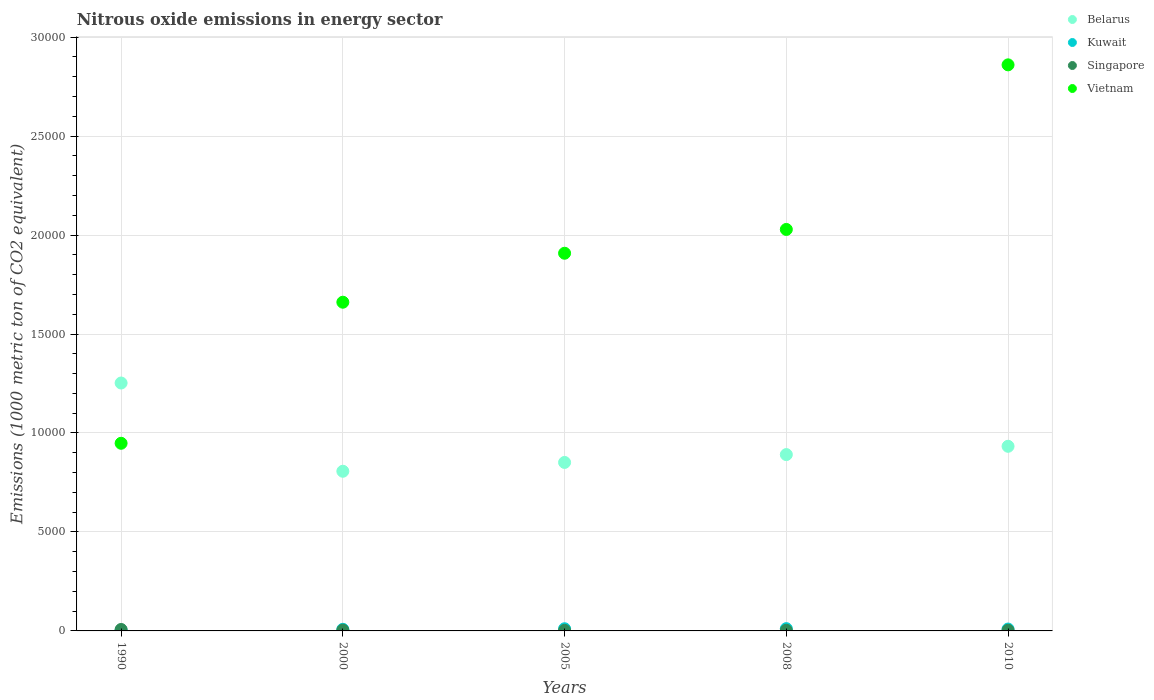How many different coloured dotlines are there?
Your answer should be very brief. 4. What is the amount of nitrous oxide emitted in Vietnam in 1990?
Offer a terse response. 9479.8. Across all years, what is the maximum amount of nitrous oxide emitted in Belarus?
Offer a very short reply. 1.25e+04. Across all years, what is the minimum amount of nitrous oxide emitted in Kuwait?
Your response must be concise. 36.7. What is the total amount of nitrous oxide emitted in Singapore in the graph?
Your answer should be compact. 210.2. What is the difference between the amount of nitrous oxide emitted in Singapore in 2000 and that in 2008?
Provide a short and direct response. 7.9. What is the difference between the amount of nitrous oxide emitted in Belarus in 2000 and the amount of nitrous oxide emitted in Vietnam in 2008?
Give a very brief answer. -1.22e+04. What is the average amount of nitrous oxide emitted in Kuwait per year?
Provide a succinct answer. 87.64. In the year 1990, what is the difference between the amount of nitrous oxide emitted in Kuwait and amount of nitrous oxide emitted in Singapore?
Your answer should be compact. -36.8. What is the ratio of the amount of nitrous oxide emitted in Singapore in 2000 to that in 2008?
Your answer should be compact. 1.24. Is the amount of nitrous oxide emitted in Kuwait in 2000 less than that in 2010?
Your answer should be very brief. Yes. Is the difference between the amount of nitrous oxide emitted in Kuwait in 2008 and 2010 greater than the difference between the amount of nitrous oxide emitted in Singapore in 2008 and 2010?
Give a very brief answer. Yes. What is the difference between the highest and the second highest amount of nitrous oxide emitted in Kuwait?
Offer a very short reply. 5.1. What is the difference between the highest and the lowest amount of nitrous oxide emitted in Kuwait?
Offer a terse response. 78.2. In how many years, is the amount of nitrous oxide emitted in Belarus greater than the average amount of nitrous oxide emitted in Belarus taken over all years?
Your answer should be very brief. 1. Is the sum of the amount of nitrous oxide emitted in Belarus in 1990 and 2005 greater than the maximum amount of nitrous oxide emitted in Vietnam across all years?
Your response must be concise. No. Is the amount of nitrous oxide emitted in Singapore strictly greater than the amount of nitrous oxide emitted in Belarus over the years?
Your answer should be very brief. No. How many dotlines are there?
Offer a terse response. 4. Are the values on the major ticks of Y-axis written in scientific E-notation?
Give a very brief answer. No. What is the title of the graph?
Offer a terse response. Nitrous oxide emissions in energy sector. What is the label or title of the X-axis?
Ensure brevity in your answer.  Years. What is the label or title of the Y-axis?
Your response must be concise. Emissions (1000 metric ton of CO2 equivalent). What is the Emissions (1000 metric ton of CO2 equivalent) of Belarus in 1990?
Offer a very short reply. 1.25e+04. What is the Emissions (1000 metric ton of CO2 equivalent) of Kuwait in 1990?
Offer a very short reply. 36.7. What is the Emissions (1000 metric ton of CO2 equivalent) in Singapore in 1990?
Your answer should be compact. 73.5. What is the Emissions (1000 metric ton of CO2 equivalent) of Vietnam in 1990?
Your answer should be very brief. 9479.8. What is the Emissions (1000 metric ton of CO2 equivalent) in Belarus in 2000?
Provide a succinct answer. 8066.2. What is the Emissions (1000 metric ton of CO2 equivalent) of Kuwait in 2000?
Provide a succinct answer. 81.9. What is the Emissions (1000 metric ton of CO2 equivalent) in Singapore in 2000?
Ensure brevity in your answer.  40.5. What is the Emissions (1000 metric ton of CO2 equivalent) in Vietnam in 2000?
Your answer should be compact. 1.66e+04. What is the Emissions (1000 metric ton of CO2 equivalent) of Belarus in 2005?
Provide a succinct answer. 8511.9. What is the Emissions (1000 metric ton of CO2 equivalent) in Kuwait in 2005?
Provide a short and direct response. 109.8. What is the Emissions (1000 metric ton of CO2 equivalent) in Singapore in 2005?
Provide a succinct answer. 29.5. What is the Emissions (1000 metric ton of CO2 equivalent) of Vietnam in 2005?
Offer a terse response. 1.91e+04. What is the Emissions (1000 metric ton of CO2 equivalent) of Belarus in 2008?
Offer a terse response. 8908.4. What is the Emissions (1000 metric ton of CO2 equivalent) of Kuwait in 2008?
Give a very brief answer. 114.9. What is the Emissions (1000 metric ton of CO2 equivalent) in Singapore in 2008?
Ensure brevity in your answer.  32.6. What is the Emissions (1000 metric ton of CO2 equivalent) in Vietnam in 2008?
Your answer should be very brief. 2.03e+04. What is the Emissions (1000 metric ton of CO2 equivalent) in Belarus in 2010?
Your answer should be very brief. 9327.9. What is the Emissions (1000 metric ton of CO2 equivalent) in Kuwait in 2010?
Your answer should be very brief. 94.9. What is the Emissions (1000 metric ton of CO2 equivalent) of Singapore in 2010?
Make the answer very short. 34.1. What is the Emissions (1000 metric ton of CO2 equivalent) of Vietnam in 2010?
Provide a succinct answer. 2.86e+04. Across all years, what is the maximum Emissions (1000 metric ton of CO2 equivalent) in Belarus?
Make the answer very short. 1.25e+04. Across all years, what is the maximum Emissions (1000 metric ton of CO2 equivalent) of Kuwait?
Your response must be concise. 114.9. Across all years, what is the maximum Emissions (1000 metric ton of CO2 equivalent) of Singapore?
Your answer should be very brief. 73.5. Across all years, what is the maximum Emissions (1000 metric ton of CO2 equivalent) in Vietnam?
Provide a succinct answer. 2.86e+04. Across all years, what is the minimum Emissions (1000 metric ton of CO2 equivalent) of Belarus?
Give a very brief answer. 8066.2. Across all years, what is the minimum Emissions (1000 metric ton of CO2 equivalent) in Kuwait?
Ensure brevity in your answer.  36.7. Across all years, what is the minimum Emissions (1000 metric ton of CO2 equivalent) of Singapore?
Your response must be concise. 29.5. Across all years, what is the minimum Emissions (1000 metric ton of CO2 equivalent) of Vietnam?
Make the answer very short. 9479.8. What is the total Emissions (1000 metric ton of CO2 equivalent) of Belarus in the graph?
Keep it short and to the point. 4.73e+04. What is the total Emissions (1000 metric ton of CO2 equivalent) of Kuwait in the graph?
Give a very brief answer. 438.2. What is the total Emissions (1000 metric ton of CO2 equivalent) in Singapore in the graph?
Give a very brief answer. 210.2. What is the total Emissions (1000 metric ton of CO2 equivalent) of Vietnam in the graph?
Your answer should be compact. 9.40e+04. What is the difference between the Emissions (1000 metric ton of CO2 equivalent) of Belarus in 1990 and that in 2000?
Make the answer very short. 4458.4. What is the difference between the Emissions (1000 metric ton of CO2 equivalent) of Kuwait in 1990 and that in 2000?
Your answer should be very brief. -45.2. What is the difference between the Emissions (1000 metric ton of CO2 equivalent) in Vietnam in 1990 and that in 2000?
Offer a terse response. -7126.8. What is the difference between the Emissions (1000 metric ton of CO2 equivalent) of Belarus in 1990 and that in 2005?
Make the answer very short. 4012.7. What is the difference between the Emissions (1000 metric ton of CO2 equivalent) of Kuwait in 1990 and that in 2005?
Keep it short and to the point. -73.1. What is the difference between the Emissions (1000 metric ton of CO2 equivalent) of Singapore in 1990 and that in 2005?
Offer a very short reply. 44. What is the difference between the Emissions (1000 metric ton of CO2 equivalent) of Vietnam in 1990 and that in 2005?
Ensure brevity in your answer.  -9601.2. What is the difference between the Emissions (1000 metric ton of CO2 equivalent) in Belarus in 1990 and that in 2008?
Your answer should be compact. 3616.2. What is the difference between the Emissions (1000 metric ton of CO2 equivalent) in Kuwait in 1990 and that in 2008?
Offer a terse response. -78.2. What is the difference between the Emissions (1000 metric ton of CO2 equivalent) of Singapore in 1990 and that in 2008?
Your response must be concise. 40.9. What is the difference between the Emissions (1000 metric ton of CO2 equivalent) of Vietnam in 1990 and that in 2008?
Give a very brief answer. -1.08e+04. What is the difference between the Emissions (1000 metric ton of CO2 equivalent) in Belarus in 1990 and that in 2010?
Your answer should be compact. 3196.7. What is the difference between the Emissions (1000 metric ton of CO2 equivalent) in Kuwait in 1990 and that in 2010?
Offer a terse response. -58.2. What is the difference between the Emissions (1000 metric ton of CO2 equivalent) of Singapore in 1990 and that in 2010?
Offer a very short reply. 39.4. What is the difference between the Emissions (1000 metric ton of CO2 equivalent) in Vietnam in 1990 and that in 2010?
Offer a very short reply. -1.91e+04. What is the difference between the Emissions (1000 metric ton of CO2 equivalent) of Belarus in 2000 and that in 2005?
Your answer should be very brief. -445.7. What is the difference between the Emissions (1000 metric ton of CO2 equivalent) in Kuwait in 2000 and that in 2005?
Your answer should be very brief. -27.9. What is the difference between the Emissions (1000 metric ton of CO2 equivalent) of Vietnam in 2000 and that in 2005?
Provide a succinct answer. -2474.4. What is the difference between the Emissions (1000 metric ton of CO2 equivalent) of Belarus in 2000 and that in 2008?
Make the answer very short. -842.2. What is the difference between the Emissions (1000 metric ton of CO2 equivalent) in Kuwait in 2000 and that in 2008?
Ensure brevity in your answer.  -33. What is the difference between the Emissions (1000 metric ton of CO2 equivalent) in Singapore in 2000 and that in 2008?
Provide a short and direct response. 7.9. What is the difference between the Emissions (1000 metric ton of CO2 equivalent) in Vietnam in 2000 and that in 2008?
Make the answer very short. -3676.6. What is the difference between the Emissions (1000 metric ton of CO2 equivalent) of Belarus in 2000 and that in 2010?
Make the answer very short. -1261.7. What is the difference between the Emissions (1000 metric ton of CO2 equivalent) in Singapore in 2000 and that in 2010?
Offer a very short reply. 6.4. What is the difference between the Emissions (1000 metric ton of CO2 equivalent) in Vietnam in 2000 and that in 2010?
Make the answer very short. -1.20e+04. What is the difference between the Emissions (1000 metric ton of CO2 equivalent) of Belarus in 2005 and that in 2008?
Offer a very short reply. -396.5. What is the difference between the Emissions (1000 metric ton of CO2 equivalent) of Singapore in 2005 and that in 2008?
Offer a very short reply. -3.1. What is the difference between the Emissions (1000 metric ton of CO2 equivalent) in Vietnam in 2005 and that in 2008?
Offer a very short reply. -1202.2. What is the difference between the Emissions (1000 metric ton of CO2 equivalent) in Belarus in 2005 and that in 2010?
Keep it short and to the point. -816. What is the difference between the Emissions (1000 metric ton of CO2 equivalent) of Vietnam in 2005 and that in 2010?
Your answer should be very brief. -9517.8. What is the difference between the Emissions (1000 metric ton of CO2 equivalent) of Belarus in 2008 and that in 2010?
Make the answer very short. -419.5. What is the difference between the Emissions (1000 metric ton of CO2 equivalent) of Singapore in 2008 and that in 2010?
Your answer should be compact. -1.5. What is the difference between the Emissions (1000 metric ton of CO2 equivalent) in Vietnam in 2008 and that in 2010?
Your answer should be compact. -8315.6. What is the difference between the Emissions (1000 metric ton of CO2 equivalent) of Belarus in 1990 and the Emissions (1000 metric ton of CO2 equivalent) of Kuwait in 2000?
Offer a terse response. 1.24e+04. What is the difference between the Emissions (1000 metric ton of CO2 equivalent) in Belarus in 1990 and the Emissions (1000 metric ton of CO2 equivalent) in Singapore in 2000?
Keep it short and to the point. 1.25e+04. What is the difference between the Emissions (1000 metric ton of CO2 equivalent) of Belarus in 1990 and the Emissions (1000 metric ton of CO2 equivalent) of Vietnam in 2000?
Provide a succinct answer. -4082. What is the difference between the Emissions (1000 metric ton of CO2 equivalent) in Kuwait in 1990 and the Emissions (1000 metric ton of CO2 equivalent) in Singapore in 2000?
Provide a succinct answer. -3.8. What is the difference between the Emissions (1000 metric ton of CO2 equivalent) in Kuwait in 1990 and the Emissions (1000 metric ton of CO2 equivalent) in Vietnam in 2000?
Make the answer very short. -1.66e+04. What is the difference between the Emissions (1000 metric ton of CO2 equivalent) in Singapore in 1990 and the Emissions (1000 metric ton of CO2 equivalent) in Vietnam in 2000?
Provide a succinct answer. -1.65e+04. What is the difference between the Emissions (1000 metric ton of CO2 equivalent) of Belarus in 1990 and the Emissions (1000 metric ton of CO2 equivalent) of Kuwait in 2005?
Offer a terse response. 1.24e+04. What is the difference between the Emissions (1000 metric ton of CO2 equivalent) in Belarus in 1990 and the Emissions (1000 metric ton of CO2 equivalent) in Singapore in 2005?
Your response must be concise. 1.25e+04. What is the difference between the Emissions (1000 metric ton of CO2 equivalent) in Belarus in 1990 and the Emissions (1000 metric ton of CO2 equivalent) in Vietnam in 2005?
Give a very brief answer. -6556.4. What is the difference between the Emissions (1000 metric ton of CO2 equivalent) in Kuwait in 1990 and the Emissions (1000 metric ton of CO2 equivalent) in Vietnam in 2005?
Your answer should be compact. -1.90e+04. What is the difference between the Emissions (1000 metric ton of CO2 equivalent) in Singapore in 1990 and the Emissions (1000 metric ton of CO2 equivalent) in Vietnam in 2005?
Provide a short and direct response. -1.90e+04. What is the difference between the Emissions (1000 metric ton of CO2 equivalent) in Belarus in 1990 and the Emissions (1000 metric ton of CO2 equivalent) in Kuwait in 2008?
Provide a short and direct response. 1.24e+04. What is the difference between the Emissions (1000 metric ton of CO2 equivalent) in Belarus in 1990 and the Emissions (1000 metric ton of CO2 equivalent) in Singapore in 2008?
Offer a terse response. 1.25e+04. What is the difference between the Emissions (1000 metric ton of CO2 equivalent) in Belarus in 1990 and the Emissions (1000 metric ton of CO2 equivalent) in Vietnam in 2008?
Provide a short and direct response. -7758.6. What is the difference between the Emissions (1000 metric ton of CO2 equivalent) of Kuwait in 1990 and the Emissions (1000 metric ton of CO2 equivalent) of Singapore in 2008?
Provide a succinct answer. 4.1. What is the difference between the Emissions (1000 metric ton of CO2 equivalent) in Kuwait in 1990 and the Emissions (1000 metric ton of CO2 equivalent) in Vietnam in 2008?
Ensure brevity in your answer.  -2.02e+04. What is the difference between the Emissions (1000 metric ton of CO2 equivalent) in Singapore in 1990 and the Emissions (1000 metric ton of CO2 equivalent) in Vietnam in 2008?
Provide a short and direct response. -2.02e+04. What is the difference between the Emissions (1000 metric ton of CO2 equivalent) of Belarus in 1990 and the Emissions (1000 metric ton of CO2 equivalent) of Kuwait in 2010?
Provide a short and direct response. 1.24e+04. What is the difference between the Emissions (1000 metric ton of CO2 equivalent) of Belarus in 1990 and the Emissions (1000 metric ton of CO2 equivalent) of Singapore in 2010?
Your response must be concise. 1.25e+04. What is the difference between the Emissions (1000 metric ton of CO2 equivalent) of Belarus in 1990 and the Emissions (1000 metric ton of CO2 equivalent) of Vietnam in 2010?
Make the answer very short. -1.61e+04. What is the difference between the Emissions (1000 metric ton of CO2 equivalent) of Kuwait in 1990 and the Emissions (1000 metric ton of CO2 equivalent) of Vietnam in 2010?
Give a very brief answer. -2.86e+04. What is the difference between the Emissions (1000 metric ton of CO2 equivalent) of Singapore in 1990 and the Emissions (1000 metric ton of CO2 equivalent) of Vietnam in 2010?
Offer a terse response. -2.85e+04. What is the difference between the Emissions (1000 metric ton of CO2 equivalent) of Belarus in 2000 and the Emissions (1000 metric ton of CO2 equivalent) of Kuwait in 2005?
Your answer should be very brief. 7956.4. What is the difference between the Emissions (1000 metric ton of CO2 equivalent) of Belarus in 2000 and the Emissions (1000 metric ton of CO2 equivalent) of Singapore in 2005?
Keep it short and to the point. 8036.7. What is the difference between the Emissions (1000 metric ton of CO2 equivalent) of Belarus in 2000 and the Emissions (1000 metric ton of CO2 equivalent) of Vietnam in 2005?
Give a very brief answer. -1.10e+04. What is the difference between the Emissions (1000 metric ton of CO2 equivalent) in Kuwait in 2000 and the Emissions (1000 metric ton of CO2 equivalent) in Singapore in 2005?
Provide a short and direct response. 52.4. What is the difference between the Emissions (1000 metric ton of CO2 equivalent) in Kuwait in 2000 and the Emissions (1000 metric ton of CO2 equivalent) in Vietnam in 2005?
Keep it short and to the point. -1.90e+04. What is the difference between the Emissions (1000 metric ton of CO2 equivalent) of Singapore in 2000 and the Emissions (1000 metric ton of CO2 equivalent) of Vietnam in 2005?
Ensure brevity in your answer.  -1.90e+04. What is the difference between the Emissions (1000 metric ton of CO2 equivalent) of Belarus in 2000 and the Emissions (1000 metric ton of CO2 equivalent) of Kuwait in 2008?
Keep it short and to the point. 7951.3. What is the difference between the Emissions (1000 metric ton of CO2 equivalent) in Belarus in 2000 and the Emissions (1000 metric ton of CO2 equivalent) in Singapore in 2008?
Make the answer very short. 8033.6. What is the difference between the Emissions (1000 metric ton of CO2 equivalent) of Belarus in 2000 and the Emissions (1000 metric ton of CO2 equivalent) of Vietnam in 2008?
Give a very brief answer. -1.22e+04. What is the difference between the Emissions (1000 metric ton of CO2 equivalent) of Kuwait in 2000 and the Emissions (1000 metric ton of CO2 equivalent) of Singapore in 2008?
Your response must be concise. 49.3. What is the difference between the Emissions (1000 metric ton of CO2 equivalent) in Kuwait in 2000 and the Emissions (1000 metric ton of CO2 equivalent) in Vietnam in 2008?
Your answer should be compact. -2.02e+04. What is the difference between the Emissions (1000 metric ton of CO2 equivalent) in Singapore in 2000 and the Emissions (1000 metric ton of CO2 equivalent) in Vietnam in 2008?
Your answer should be very brief. -2.02e+04. What is the difference between the Emissions (1000 metric ton of CO2 equivalent) in Belarus in 2000 and the Emissions (1000 metric ton of CO2 equivalent) in Kuwait in 2010?
Give a very brief answer. 7971.3. What is the difference between the Emissions (1000 metric ton of CO2 equivalent) of Belarus in 2000 and the Emissions (1000 metric ton of CO2 equivalent) of Singapore in 2010?
Make the answer very short. 8032.1. What is the difference between the Emissions (1000 metric ton of CO2 equivalent) of Belarus in 2000 and the Emissions (1000 metric ton of CO2 equivalent) of Vietnam in 2010?
Offer a very short reply. -2.05e+04. What is the difference between the Emissions (1000 metric ton of CO2 equivalent) of Kuwait in 2000 and the Emissions (1000 metric ton of CO2 equivalent) of Singapore in 2010?
Make the answer very short. 47.8. What is the difference between the Emissions (1000 metric ton of CO2 equivalent) of Kuwait in 2000 and the Emissions (1000 metric ton of CO2 equivalent) of Vietnam in 2010?
Offer a terse response. -2.85e+04. What is the difference between the Emissions (1000 metric ton of CO2 equivalent) in Singapore in 2000 and the Emissions (1000 metric ton of CO2 equivalent) in Vietnam in 2010?
Offer a terse response. -2.86e+04. What is the difference between the Emissions (1000 metric ton of CO2 equivalent) in Belarus in 2005 and the Emissions (1000 metric ton of CO2 equivalent) in Kuwait in 2008?
Provide a succinct answer. 8397. What is the difference between the Emissions (1000 metric ton of CO2 equivalent) of Belarus in 2005 and the Emissions (1000 metric ton of CO2 equivalent) of Singapore in 2008?
Give a very brief answer. 8479.3. What is the difference between the Emissions (1000 metric ton of CO2 equivalent) in Belarus in 2005 and the Emissions (1000 metric ton of CO2 equivalent) in Vietnam in 2008?
Make the answer very short. -1.18e+04. What is the difference between the Emissions (1000 metric ton of CO2 equivalent) in Kuwait in 2005 and the Emissions (1000 metric ton of CO2 equivalent) in Singapore in 2008?
Provide a short and direct response. 77.2. What is the difference between the Emissions (1000 metric ton of CO2 equivalent) of Kuwait in 2005 and the Emissions (1000 metric ton of CO2 equivalent) of Vietnam in 2008?
Your answer should be very brief. -2.02e+04. What is the difference between the Emissions (1000 metric ton of CO2 equivalent) of Singapore in 2005 and the Emissions (1000 metric ton of CO2 equivalent) of Vietnam in 2008?
Provide a short and direct response. -2.03e+04. What is the difference between the Emissions (1000 metric ton of CO2 equivalent) of Belarus in 2005 and the Emissions (1000 metric ton of CO2 equivalent) of Kuwait in 2010?
Give a very brief answer. 8417. What is the difference between the Emissions (1000 metric ton of CO2 equivalent) in Belarus in 2005 and the Emissions (1000 metric ton of CO2 equivalent) in Singapore in 2010?
Provide a succinct answer. 8477.8. What is the difference between the Emissions (1000 metric ton of CO2 equivalent) in Belarus in 2005 and the Emissions (1000 metric ton of CO2 equivalent) in Vietnam in 2010?
Ensure brevity in your answer.  -2.01e+04. What is the difference between the Emissions (1000 metric ton of CO2 equivalent) in Kuwait in 2005 and the Emissions (1000 metric ton of CO2 equivalent) in Singapore in 2010?
Your answer should be compact. 75.7. What is the difference between the Emissions (1000 metric ton of CO2 equivalent) in Kuwait in 2005 and the Emissions (1000 metric ton of CO2 equivalent) in Vietnam in 2010?
Make the answer very short. -2.85e+04. What is the difference between the Emissions (1000 metric ton of CO2 equivalent) in Singapore in 2005 and the Emissions (1000 metric ton of CO2 equivalent) in Vietnam in 2010?
Make the answer very short. -2.86e+04. What is the difference between the Emissions (1000 metric ton of CO2 equivalent) of Belarus in 2008 and the Emissions (1000 metric ton of CO2 equivalent) of Kuwait in 2010?
Give a very brief answer. 8813.5. What is the difference between the Emissions (1000 metric ton of CO2 equivalent) in Belarus in 2008 and the Emissions (1000 metric ton of CO2 equivalent) in Singapore in 2010?
Make the answer very short. 8874.3. What is the difference between the Emissions (1000 metric ton of CO2 equivalent) of Belarus in 2008 and the Emissions (1000 metric ton of CO2 equivalent) of Vietnam in 2010?
Your answer should be very brief. -1.97e+04. What is the difference between the Emissions (1000 metric ton of CO2 equivalent) in Kuwait in 2008 and the Emissions (1000 metric ton of CO2 equivalent) in Singapore in 2010?
Your answer should be very brief. 80.8. What is the difference between the Emissions (1000 metric ton of CO2 equivalent) in Kuwait in 2008 and the Emissions (1000 metric ton of CO2 equivalent) in Vietnam in 2010?
Give a very brief answer. -2.85e+04. What is the difference between the Emissions (1000 metric ton of CO2 equivalent) in Singapore in 2008 and the Emissions (1000 metric ton of CO2 equivalent) in Vietnam in 2010?
Your answer should be very brief. -2.86e+04. What is the average Emissions (1000 metric ton of CO2 equivalent) of Belarus per year?
Make the answer very short. 9467.8. What is the average Emissions (1000 metric ton of CO2 equivalent) of Kuwait per year?
Ensure brevity in your answer.  87.64. What is the average Emissions (1000 metric ton of CO2 equivalent) of Singapore per year?
Give a very brief answer. 42.04. What is the average Emissions (1000 metric ton of CO2 equivalent) of Vietnam per year?
Give a very brief answer. 1.88e+04. In the year 1990, what is the difference between the Emissions (1000 metric ton of CO2 equivalent) of Belarus and Emissions (1000 metric ton of CO2 equivalent) of Kuwait?
Give a very brief answer. 1.25e+04. In the year 1990, what is the difference between the Emissions (1000 metric ton of CO2 equivalent) of Belarus and Emissions (1000 metric ton of CO2 equivalent) of Singapore?
Keep it short and to the point. 1.25e+04. In the year 1990, what is the difference between the Emissions (1000 metric ton of CO2 equivalent) of Belarus and Emissions (1000 metric ton of CO2 equivalent) of Vietnam?
Make the answer very short. 3044.8. In the year 1990, what is the difference between the Emissions (1000 metric ton of CO2 equivalent) of Kuwait and Emissions (1000 metric ton of CO2 equivalent) of Singapore?
Give a very brief answer. -36.8. In the year 1990, what is the difference between the Emissions (1000 metric ton of CO2 equivalent) of Kuwait and Emissions (1000 metric ton of CO2 equivalent) of Vietnam?
Give a very brief answer. -9443.1. In the year 1990, what is the difference between the Emissions (1000 metric ton of CO2 equivalent) of Singapore and Emissions (1000 metric ton of CO2 equivalent) of Vietnam?
Ensure brevity in your answer.  -9406.3. In the year 2000, what is the difference between the Emissions (1000 metric ton of CO2 equivalent) in Belarus and Emissions (1000 metric ton of CO2 equivalent) in Kuwait?
Ensure brevity in your answer.  7984.3. In the year 2000, what is the difference between the Emissions (1000 metric ton of CO2 equivalent) in Belarus and Emissions (1000 metric ton of CO2 equivalent) in Singapore?
Provide a succinct answer. 8025.7. In the year 2000, what is the difference between the Emissions (1000 metric ton of CO2 equivalent) of Belarus and Emissions (1000 metric ton of CO2 equivalent) of Vietnam?
Provide a succinct answer. -8540.4. In the year 2000, what is the difference between the Emissions (1000 metric ton of CO2 equivalent) of Kuwait and Emissions (1000 metric ton of CO2 equivalent) of Singapore?
Ensure brevity in your answer.  41.4. In the year 2000, what is the difference between the Emissions (1000 metric ton of CO2 equivalent) in Kuwait and Emissions (1000 metric ton of CO2 equivalent) in Vietnam?
Keep it short and to the point. -1.65e+04. In the year 2000, what is the difference between the Emissions (1000 metric ton of CO2 equivalent) in Singapore and Emissions (1000 metric ton of CO2 equivalent) in Vietnam?
Your answer should be very brief. -1.66e+04. In the year 2005, what is the difference between the Emissions (1000 metric ton of CO2 equivalent) of Belarus and Emissions (1000 metric ton of CO2 equivalent) of Kuwait?
Your response must be concise. 8402.1. In the year 2005, what is the difference between the Emissions (1000 metric ton of CO2 equivalent) in Belarus and Emissions (1000 metric ton of CO2 equivalent) in Singapore?
Make the answer very short. 8482.4. In the year 2005, what is the difference between the Emissions (1000 metric ton of CO2 equivalent) in Belarus and Emissions (1000 metric ton of CO2 equivalent) in Vietnam?
Provide a short and direct response. -1.06e+04. In the year 2005, what is the difference between the Emissions (1000 metric ton of CO2 equivalent) of Kuwait and Emissions (1000 metric ton of CO2 equivalent) of Singapore?
Ensure brevity in your answer.  80.3. In the year 2005, what is the difference between the Emissions (1000 metric ton of CO2 equivalent) of Kuwait and Emissions (1000 metric ton of CO2 equivalent) of Vietnam?
Provide a short and direct response. -1.90e+04. In the year 2005, what is the difference between the Emissions (1000 metric ton of CO2 equivalent) of Singapore and Emissions (1000 metric ton of CO2 equivalent) of Vietnam?
Ensure brevity in your answer.  -1.91e+04. In the year 2008, what is the difference between the Emissions (1000 metric ton of CO2 equivalent) of Belarus and Emissions (1000 metric ton of CO2 equivalent) of Kuwait?
Your answer should be compact. 8793.5. In the year 2008, what is the difference between the Emissions (1000 metric ton of CO2 equivalent) of Belarus and Emissions (1000 metric ton of CO2 equivalent) of Singapore?
Your answer should be very brief. 8875.8. In the year 2008, what is the difference between the Emissions (1000 metric ton of CO2 equivalent) of Belarus and Emissions (1000 metric ton of CO2 equivalent) of Vietnam?
Your response must be concise. -1.14e+04. In the year 2008, what is the difference between the Emissions (1000 metric ton of CO2 equivalent) in Kuwait and Emissions (1000 metric ton of CO2 equivalent) in Singapore?
Make the answer very short. 82.3. In the year 2008, what is the difference between the Emissions (1000 metric ton of CO2 equivalent) of Kuwait and Emissions (1000 metric ton of CO2 equivalent) of Vietnam?
Offer a very short reply. -2.02e+04. In the year 2008, what is the difference between the Emissions (1000 metric ton of CO2 equivalent) in Singapore and Emissions (1000 metric ton of CO2 equivalent) in Vietnam?
Keep it short and to the point. -2.03e+04. In the year 2010, what is the difference between the Emissions (1000 metric ton of CO2 equivalent) of Belarus and Emissions (1000 metric ton of CO2 equivalent) of Kuwait?
Your response must be concise. 9233. In the year 2010, what is the difference between the Emissions (1000 metric ton of CO2 equivalent) of Belarus and Emissions (1000 metric ton of CO2 equivalent) of Singapore?
Your response must be concise. 9293.8. In the year 2010, what is the difference between the Emissions (1000 metric ton of CO2 equivalent) of Belarus and Emissions (1000 metric ton of CO2 equivalent) of Vietnam?
Provide a succinct answer. -1.93e+04. In the year 2010, what is the difference between the Emissions (1000 metric ton of CO2 equivalent) of Kuwait and Emissions (1000 metric ton of CO2 equivalent) of Singapore?
Your answer should be compact. 60.8. In the year 2010, what is the difference between the Emissions (1000 metric ton of CO2 equivalent) in Kuwait and Emissions (1000 metric ton of CO2 equivalent) in Vietnam?
Offer a terse response. -2.85e+04. In the year 2010, what is the difference between the Emissions (1000 metric ton of CO2 equivalent) of Singapore and Emissions (1000 metric ton of CO2 equivalent) of Vietnam?
Give a very brief answer. -2.86e+04. What is the ratio of the Emissions (1000 metric ton of CO2 equivalent) of Belarus in 1990 to that in 2000?
Make the answer very short. 1.55. What is the ratio of the Emissions (1000 metric ton of CO2 equivalent) of Kuwait in 1990 to that in 2000?
Offer a very short reply. 0.45. What is the ratio of the Emissions (1000 metric ton of CO2 equivalent) in Singapore in 1990 to that in 2000?
Make the answer very short. 1.81. What is the ratio of the Emissions (1000 metric ton of CO2 equivalent) in Vietnam in 1990 to that in 2000?
Give a very brief answer. 0.57. What is the ratio of the Emissions (1000 metric ton of CO2 equivalent) in Belarus in 1990 to that in 2005?
Make the answer very short. 1.47. What is the ratio of the Emissions (1000 metric ton of CO2 equivalent) of Kuwait in 1990 to that in 2005?
Your answer should be compact. 0.33. What is the ratio of the Emissions (1000 metric ton of CO2 equivalent) of Singapore in 1990 to that in 2005?
Provide a short and direct response. 2.49. What is the ratio of the Emissions (1000 metric ton of CO2 equivalent) of Vietnam in 1990 to that in 2005?
Make the answer very short. 0.5. What is the ratio of the Emissions (1000 metric ton of CO2 equivalent) in Belarus in 1990 to that in 2008?
Your response must be concise. 1.41. What is the ratio of the Emissions (1000 metric ton of CO2 equivalent) in Kuwait in 1990 to that in 2008?
Give a very brief answer. 0.32. What is the ratio of the Emissions (1000 metric ton of CO2 equivalent) of Singapore in 1990 to that in 2008?
Keep it short and to the point. 2.25. What is the ratio of the Emissions (1000 metric ton of CO2 equivalent) in Vietnam in 1990 to that in 2008?
Ensure brevity in your answer.  0.47. What is the ratio of the Emissions (1000 metric ton of CO2 equivalent) of Belarus in 1990 to that in 2010?
Your answer should be compact. 1.34. What is the ratio of the Emissions (1000 metric ton of CO2 equivalent) of Kuwait in 1990 to that in 2010?
Provide a succinct answer. 0.39. What is the ratio of the Emissions (1000 metric ton of CO2 equivalent) in Singapore in 1990 to that in 2010?
Make the answer very short. 2.16. What is the ratio of the Emissions (1000 metric ton of CO2 equivalent) of Vietnam in 1990 to that in 2010?
Give a very brief answer. 0.33. What is the ratio of the Emissions (1000 metric ton of CO2 equivalent) of Belarus in 2000 to that in 2005?
Your answer should be very brief. 0.95. What is the ratio of the Emissions (1000 metric ton of CO2 equivalent) in Kuwait in 2000 to that in 2005?
Your answer should be very brief. 0.75. What is the ratio of the Emissions (1000 metric ton of CO2 equivalent) of Singapore in 2000 to that in 2005?
Offer a terse response. 1.37. What is the ratio of the Emissions (1000 metric ton of CO2 equivalent) in Vietnam in 2000 to that in 2005?
Your answer should be very brief. 0.87. What is the ratio of the Emissions (1000 metric ton of CO2 equivalent) of Belarus in 2000 to that in 2008?
Provide a succinct answer. 0.91. What is the ratio of the Emissions (1000 metric ton of CO2 equivalent) of Kuwait in 2000 to that in 2008?
Provide a succinct answer. 0.71. What is the ratio of the Emissions (1000 metric ton of CO2 equivalent) in Singapore in 2000 to that in 2008?
Offer a very short reply. 1.24. What is the ratio of the Emissions (1000 metric ton of CO2 equivalent) of Vietnam in 2000 to that in 2008?
Your answer should be very brief. 0.82. What is the ratio of the Emissions (1000 metric ton of CO2 equivalent) of Belarus in 2000 to that in 2010?
Give a very brief answer. 0.86. What is the ratio of the Emissions (1000 metric ton of CO2 equivalent) of Kuwait in 2000 to that in 2010?
Your answer should be very brief. 0.86. What is the ratio of the Emissions (1000 metric ton of CO2 equivalent) in Singapore in 2000 to that in 2010?
Ensure brevity in your answer.  1.19. What is the ratio of the Emissions (1000 metric ton of CO2 equivalent) of Vietnam in 2000 to that in 2010?
Your answer should be very brief. 0.58. What is the ratio of the Emissions (1000 metric ton of CO2 equivalent) of Belarus in 2005 to that in 2008?
Keep it short and to the point. 0.96. What is the ratio of the Emissions (1000 metric ton of CO2 equivalent) in Kuwait in 2005 to that in 2008?
Provide a short and direct response. 0.96. What is the ratio of the Emissions (1000 metric ton of CO2 equivalent) in Singapore in 2005 to that in 2008?
Your answer should be compact. 0.9. What is the ratio of the Emissions (1000 metric ton of CO2 equivalent) in Vietnam in 2005 to that in 2008?
Your answer should be compact. 0.94. What is the ratio of the Emissions (1000 metric ton of CO2 equivalent) of Belarus in 2005 to that in 2010?
Offer a very short reply. 0.91. What is the ratio of the Emissions (1000 metric ton of CO2 equivalent) of Kuwait in 2005 to that in 2010?
Keep it short and to the point. 1.16. What is the ratio of the Emissions (1000 metric ton of CO2 equivalent) in Singapore in 2005 to that in 2010?
Ensure brevity in your answer.  0.87. What is the ratio of the Emissions (1000 metric ton of CO2 equivalent) in Vietnam in 2005 to that in 2010?
Offer a terse response. 0.67. What is the ratio of the Emissions (1000 metric ton of CO2 equivalent) of Belarus in 2008 to that in 2010?
Provide a short and direct response. 0.95. What is the ratio of the Emissions (1000 metric ton of CO2 equivalent) of Kuwait in 2008 to that in 2010?
Ensure brevity in your answer.  1.21. What is the ratio of the Emissions (1000 metric ton of CO2 equivalent) in Singapore in 2008 to that in 2010?
Your answer should be compact. 0.96. What is the ratio of the Emissions (1000 metric ton of CO2 equivalent) of Vietnam in 2008 to that in 2010?
Give a very brief answer. 0.71. What is the difference between the highest and the second highest Emissions (1000 metric ton of CO2 equivalent) in Belarus?
Your answer should be very brief. 3196.7. What is the difference between the highest and the second highest Emissions (1000 metric ton of CO2 equivalent) of Kuwait?
Your answer should be very brief. 5.1. What is the difference between the highest and the second highest Emissions (1000 metric ton of CO2 equivalent) in Vietnam?
Ensure brevity in your answer.  8315.6. What is the difference between the highest and the lowest Emissions (1000 metric ton of CO2 equivalent) of Belarus?
Offer a very short reply. 4458.4. What is the difference between the highest and the lowest Emissions (1000 metric ton of CO2 equivalent) in Kuwait?
Make the answer very short. 78.2. What is the difference between the highest and the lowest Emissions (1000 metric ton of CO2 equivalent) of Singapore?
Give a very brief answer. 44. What is the difference between the highest and the lowest Emissions (1000 metric ton of CO2 equivalent) in Vietnam?
Provide a succinct answer. 1.91e+04. 